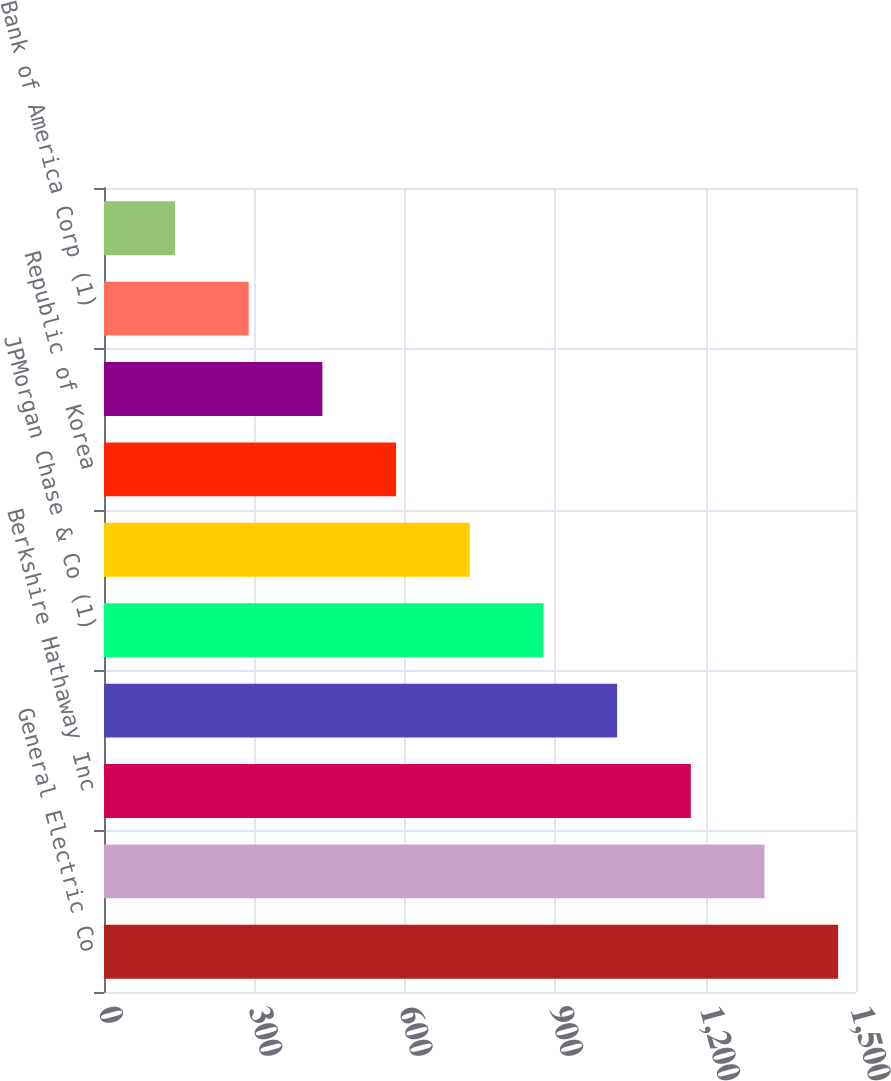<chart> <loc_0><loc_0><loc_500><loc_500><bar_chart><fcel>General Electric Co<fcel>AT&T Inc<fcel>Berkshire Hathaway Inc<fcel>Prudential Financial Inc<fcel>JPMorgan Chase & Co (1)<fcel>Verizon Communications Inc<fcel>Republic of Korea<fcel>Merck & Co Inc<fcel>Bank of America Corp (1)<fcel>News Corp<nl><fcel>1464.43<fcel>1317.46<fcel>1170.49<fcel>1023.52<fcel>876.55<fcel>729.58<fcel>582.61<fcel>435.64<fcel>288.67<fcel>141.7<nl></chart> 